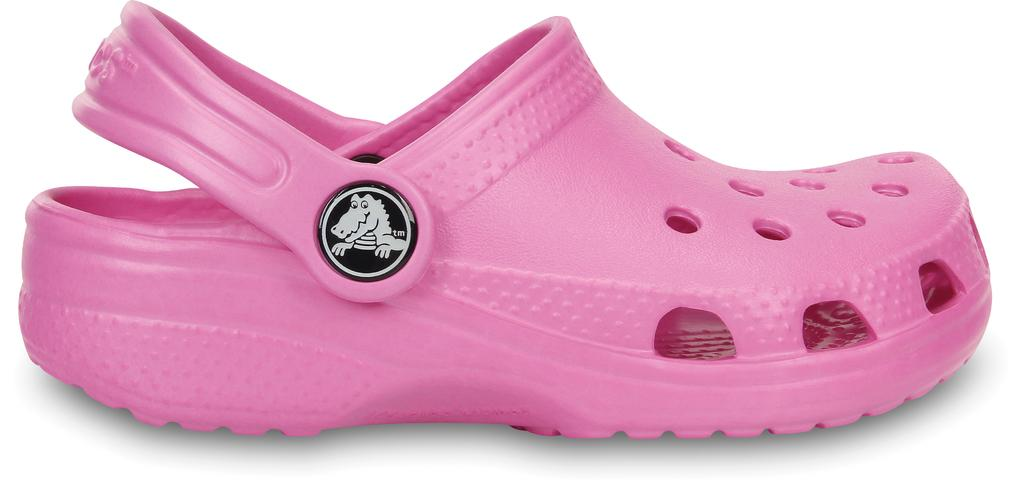What type of object is present in the image? The image contains a footwear. What is the color of the footwear? The footwear is pink in color. Can you identify the brand of the footwear? Yes, the footwear is of "Crocs" brand. How many roses are present in the image? There are no roses present in the image; it features a pink Crocs footwear. What type of cap is being worn by the person in the image? There is no person or cap visible in the image, only a pink Crocs footwear. 